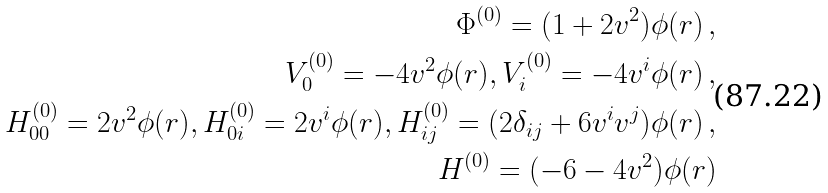Convert formula to latex. <formula><loc_0><loc_0><loc_500><loc_500>\Phi ^ { ( 0 ) } = ( 1 + 2 v ^ { 2 } ) \phi ( r ) \, , \\ V _ { 0 } ^ { ( 0 ) } = - 4 v ^ { 2 } \phi ( r ) , V _ { i } ^ { ( 0 ) } = - 4 v ^ { i } \phi ( r ) \, , \\ H _ { 0 0 } ^ { ( 0 ) } = 2 v ^ { 2 } \phi ( r ) , H _ { 0 i } ^ { ( 0 ) } = 2 v ^ { i } \phi ( r ) , H _ { i j } ^ { ( 0 ) } = ( 2 \delta _ { i j } + 6 v ^ { i } v ^ { j } ) \phi ( r ) \, , \\ H ^ { ( 0 ) } = ( - 6 - 4 v ^ { 2 } ) \phi ( r )</formula> 